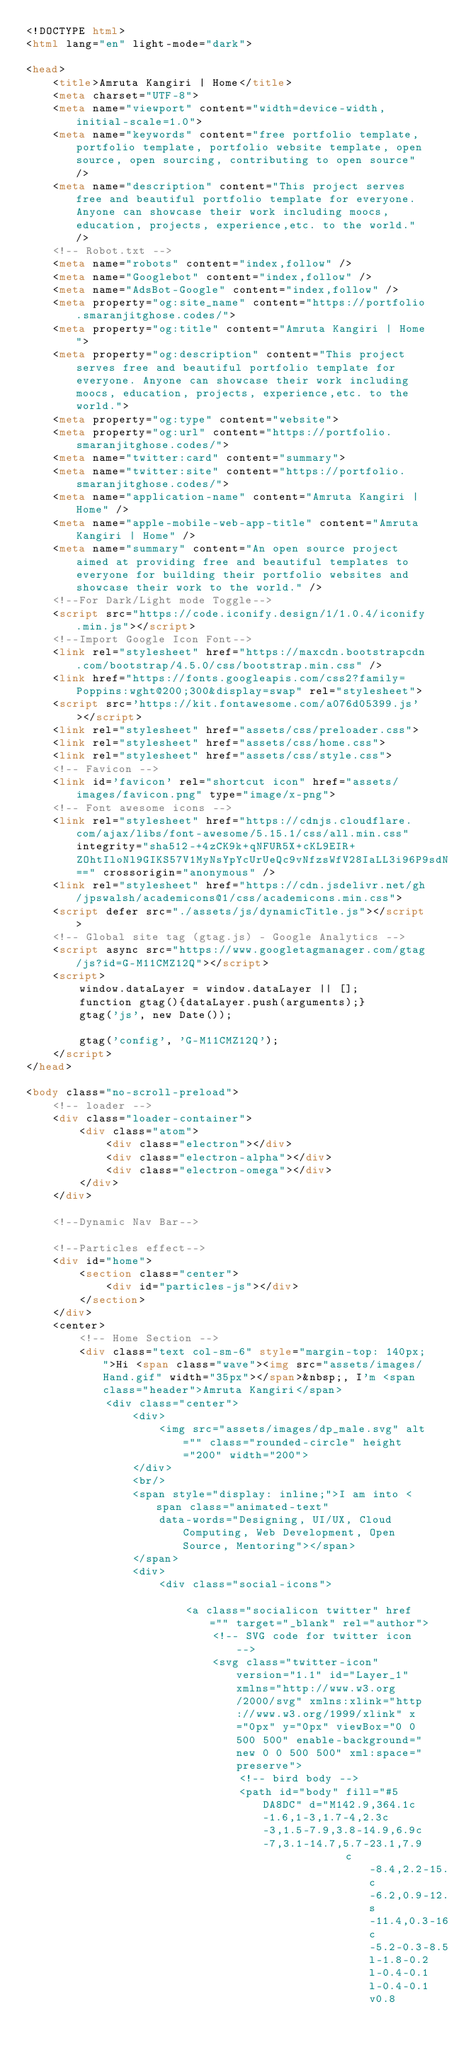<code> <loc_0><loc_0><loc_500><loc_500><_HTML_><!DOCTYPE html>
<html lang="en" light-mode="dark">

<head>
    <title>Amruta Kangiri | Home</title>
    <meta charset="UTF-8">
    <meta name="viewport" content="width=device-width, initial-scale=1.0">
    <meta name="keywords" content="free portfolio template,portfolio template, portfolio website template, open source, open sourcing, contributing to open source" />
    <meta name="description" content="This project serves free and beautiful portfolio template for everyone. Anyone can showcase their work including moocs, education, projects, experience,etc. to the world." />
    <!-- Robot.txt -->
    <meta name="robots" content="index,follow" />
    <meta name="Googlebot" content="index,follow" />
    <meta name="AdsBot-Google" content="index,follow" />
    <meta property="og:site_name" content="https://portfolio.smaranjitghose.codes/">
    <meta property="og:title" content="Amruta Kangiri | Home">
    <meta property="og:description" content="This project serves free and beautiful portfolio template for everyone. Anyone can showcase their work including moocs, education, projects, experience,etc. to the world.">
    <meta property="og:type" content="website">
    <meta property="og:url" content="https://portfolio.smaranjitghose.codes/">
    <meta name="twitter:card" content="summary">
    <meta name="twitter:site" content="https://portfolio.smaranjitghose.codes/">
    <meta name="application-name" content="Amruta Kangiri | Home" />
    <meta name="apple-mobile-web-app-title" content="Amruta Kangiri | Home" />
    <meta name="summary" content="An open source project aimed at providing free and beautiful templates to everyone for building their portfolio websites and showcase their work to the world." />
    <!--For Dark/Light mode Toggle-->
    <script src="https://code.iconify.design/1/1.0.4/iconify.min.js"></script>
    <!--Import Google Icon Font-->
    <link rel="stylesheet" href="https://maxcdn.bootstrapcdn.com/bootstrap/4.5.0/css/bootstrap.min.css" />
    <link href="https://fonts.googleapis.com/css2?family=Poppins:wght@200;300&display=swap" rel="stylesheet">
    <script src='https://kit.fontawesome.com/a076d05399.js'></script>
    <link rel="stylesheet" href="assets/css/preloader.css">
    <link rel="stylesheet" href="assets/css/home.css">
    <link rel="stylesheet" href="assets/css/style.css">
    <!-- Favicon -->
    <link id='favicon' rel="shortcut icon" href="assets/images/favicon.png" type="image/x-png">
    <!-- Font awesome icons -->
    <link rel="stylesheet" href="https://cdnjs.cloudflare.com/ajax/libs/font-awesome/5.15.1/css/all.min.css" integrity="sha512-+4zCK9k+qNFUR5X+cKL9EIR+ZOhtIloNl9GIKS57V1MyNsYpYcUrUeQc9vNfzsWfV28IaLL3i96P9sdNyeRssA==" crossorigin="anonymous" />
    <link rel="stylesheet" href="https://cdn.jsdelivr.net/gh/jpswalsh/academicons@1/css/academicons.min.css">
    <script defer src="./assets/js/dynamicTitle.js"></script>
    <!-- Global site tag (gtag.js) - Google Analytics -->
    <script async src="https://www.googletagmanager.com/gtag/js?id=G-M11CMZ12Q"></script>
    <script>
        window.dataLayer = window.dataLayer || [];
        function gtag(){dataLayer.push(arguments);}
        gtag('js', new Date());

        gtag('config', 'G-M11CMZ12Q');
    </script>
</head>

<body class="no-scroll-preload">
    <!-- loader -->
    <div class="loader-container">
        <div class="atom">
            <div class="electron"></div>
            <div class="electron-alpha"></div>
            <div class="electron-omega"></div>
        </div>
    </div>

    <!--Dynamic Nav Bar-->

    <!--Particles effect-->
    <div id="home">
        <section class="center">
            <div id="particles-js"></div>
        </section>
    </div>
    <center>
        <!-- Home Section -->
        <div class="text col-sm-6" style="margin-top: 140px;">Hi <span class="wave"><img src="assets/images/Hand.gif" width="35px"></span>&nbsp;, I'm <span class="header">Amruta Kangiri</span>
            <div class="center">
                <div>
                    <img src="assets/images/dp_male.svg" alt="" class="rounded-circle" height="200" width="200">
                </div>
                <br/>
                <span style="display: inline;">I am into <span class="animated-text"
                    data-words="Designing, UI/UX, Cloud Computing, Web Development, Open Source, Mentoring"></span>
                </span>
                <div>
                    <div class="social-icons">

                        <a class="socialicon twitter" href="" target="_blank" rel="author">
                            <!-- SVG code for twitter icon -->
                            <svg class="twitter-icon" version="1.1" id="Layer_1" xmlns="http://www.w3.org/2000/svg" xmlns:xlink="http://www.w3.org/1999/xlink" x="0px" y="0px" viewBox="0 0 500 500" enable-background="new 0 0 500 500" xml:space="preserve">
                                <!-- bird body -->
                                <path id="body" fill="#5DA8DC" d="M142.9,364.1c-1.6,1-3,1.7-4,2.3c-3,1.5-7.9,3.8-14.9,6.9c-7,3.1-14.7,5.7-23.1,7.9
                                                c-8.4,2.2-15.6,3.8-21.8,4.7c-6.2,0.9-12.2,1.5-18.1,1.8s-11.4,0.3-16.7,0c-5.2-0.3-8.5-0.5-9.6-0.6l-1.8-0.2l-0.4-0.1l-0.4-0.1v0.8</code> 